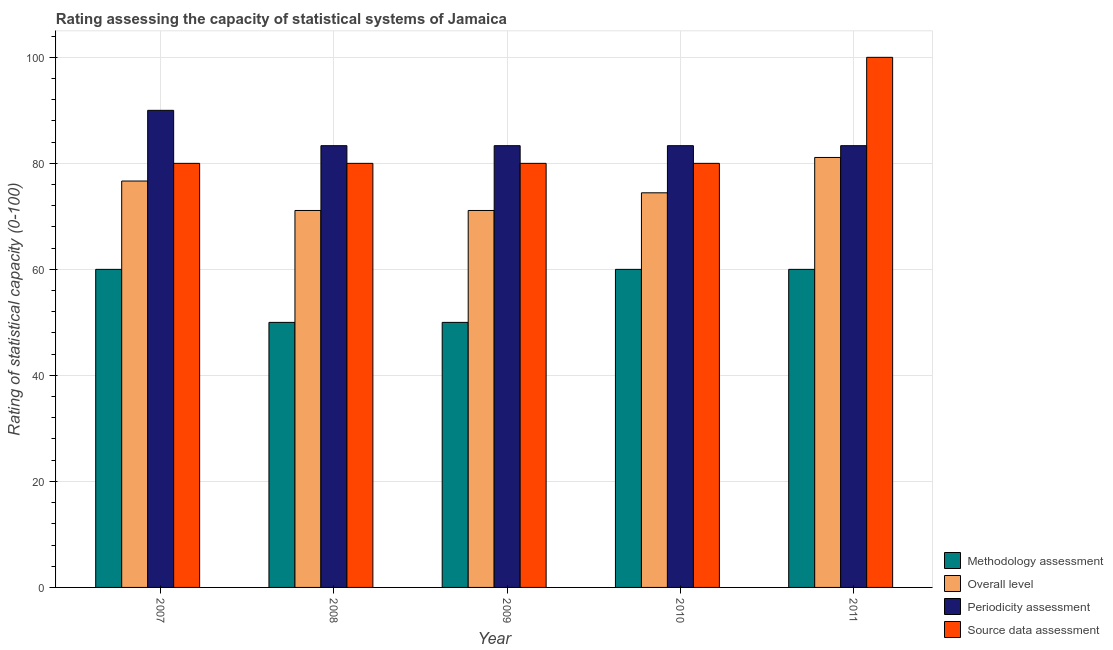How many different coloured bars are there?
Ensure brevity in your answer.  4. How many bars are there on the 3rd tick from the left?
Ensure brevity in your answer.  4. How many bars are there on the 5th tick from the right?
Your response must be concise. 4. What is the label of the 3rd group of bars from the left?
Your answer should be very brief. 2009. What is the source data assessment rating in 2008?
Provide a succinct answer. 80. Across all years, what is the maximum source data assessment rating?
Your answer should be very brief. 100. Across all years, what is the minimum methodology assessment rating?
Offer a terse response. 50. In which year was the methodology assessment rating maximum?
Ensure brevity in your answer.  2007. What is the total periodicity assessment rating in the graph?
Your answer should be very brief. 423.33. What is the difference between the periodicity assessment rating in 2009 and that in 2011?
Offer a terse response. 0. What is the average source data assessment rating per year?
Provide a short and direct response. 84. In the year 2008, what is the difference between the methodology assessment rating and periodicity assessment rating?
Your response must be concise. 0. What is the ratio of the overall level rating in 2008 to that in 2011?
Provide a short and direct response. 0.88. Is the overall level rating in 2010 less than that in 2011?
Provide a succinct answer. Yes. Is the difference between the methodology assessment rating in 2008 and 2011 greater than the difference between the source data assessment rating in 2008 and 2011?
Offer a terse response. No. What is the difference between the highest and the second highest overall level rating?
Provide a short and direct response. 4.44. What is the difference between the highest and the lowest source data assessment rating?
Your answer should be very brief. 20. Is the sum of the periodicity assessment rating in 2009 and 2010 greater than the maximum overall level rating across all years?
Give a very brief answer. Yes. Is it the case that in every year, the sum of the periodicity assessment rating and overall level rating is greater than the sum of source data assessment rating and methodology assessment rating?
Your answer should be very brief. Yes. What does the 1st bar from the left in 2009 represents?
Your response must be concise. Methodology assessment. What does the 1st bar from the right in 2008 represents?
Keep it short and to the point. Source data assessment. Is it the case that in every year, the sum of the methodology assessment rating and overall level rating is greater than the periodicity assessment rating?
Ensure brevity in your answer.  Yes. How many bars are there?
Ensure brevity in your answer.  20. Does the graph contain any zero values?
Offer a very short reply. No. How are the legend labels stacked?
Keep it short and to the point. Vertical. What is the title of the graph?
Offer a very short reply. Rating assessing the capacity of statistical systems of Jamaica. Does "Iceland" appear as one of the legend labels in the graph?
Offer a very short reply. No. What is the label or title of the Y-axis?
Offer a terse response. Rating of statistical capacity (0-100). What is the Rating of statistical capacity (0-100) in Methodology assessment in 2007?
Provide a succinct answer. 60. What is the Rating of statistical capacity (0-100) in Overall level in 2007?
Keep it short and to the point. 76.67. What is the Rating of statistical capacity (0-100) of Periodicity assessment in 2007?
Give a very brief answer. 90. What is the Rating of statistical capacity (0-100) of Source data assessment in 2007?
Provide a succinct answer. 80. What is the Rating of statistical capacity (0-100) in Methodology assessment in 2008?
Keep it short and to the point. 50. What is the Rating of statistical capacity (0-100) in Overall level in 2008?
Keep it short and to the point. 71.11. What is the Rating of statistical capacity (0-100) in Periodicity assessment in 2008?
Make the answer very short. 83.33. What is the Rating of statistical capacity (0-100) of Source data assessment in 2008?
Ensure brevity in your answer.  80. What is the Rating of statistical capacity (0-100) of Methodology assessment in 2009?
Provide a short and direct response. 50. What is the Rating of statistical capacity (0-100) of Overall level in 2009?
Your answer should be compact. 71.11. What is the Rating of statistical capacity (0-100) in Periodicity assessment in 2009?
Offer a terse response. 83.33. What is the Rating of statistical capacity (0-100) in Source data assessment in 2009?
Provide a short and direct response. 80. What is the Rating of statistical capacity (0-100) in Methodology assessment in 2010?
Provide a short and direct response. 60. What is the Rating of statistical capacity (0-100) of Overall level in 2010?
Ensure brevity in your answer.  74.44. What is the Rating of statistical capacity (0-100) in Periodicity assessment in 2010?
Your response must be concise. 83.33. What is the Rating of statistical capacity (0-100) of Overall level in 2011?
Give a very brief answer. 81.11. What is the Rating of statistical capacity (0-100) in Periodicity assessment in 2011?
Your response must be concise. 83.33. Across all years, what is the maximum Rating of statistical capacity (0-100) of Methodology assessment?
Ensure brevity in your answer.  60. Across all years, what is the maximum Rating of statistical capacity (0-100) in Overall level?
Your answer should be compact. 81.11. Across all years, what is the maximum Rating of statistical capacity (0-100) in Periodicity assessment?
Your answer should be very brief. 90. Across all years, what is the maximum Rating of statistical capacity (0-100) in Source data assessment?
Give a very brief answer. 100. Across all years, what is the minimum Rating of statistical capacity (0-100) of Overall level?
Provide a succinct answer. 71.11. Across all years, what is the minimum Rating of statistical capacity (0-100) of Periodicity assessment?
Keep it short and to the point. 83.33. What is the total Rating of statistical capacity (0-100) of Methodology assessment in the graph?
Your answer should be compact. 280. What is the total Rating of statistical capacity (0-100) in Overall level in the graph?
Offer a very short reply. 374.44. What is the total Rating of statistical capacity (0-100) of Periodicity assessment in the graph?
Keep it short and to the point. 423.33. What is the total Rating of statistical capacity (0-100) of Source data assessment in the graph?
Your response must be concise. 420. What is the difference between the Rating of statistical capacity (0-100) in Methodology assessment in 2007 and that in 2008?
Give a very brief answer. 10. What is the difference between the Rating of statistical capacity (0-100) of Overall level in 2007 and that in 2008?
Keep it short and to the point. 5.56. What is the difference between the Rating of statistical capacity (0-100) in Periodicity assessment in 2007 and that in 2008?
Provide a succinct answer. 6.67. What is the difference between the Rating of statistical capacity (0-100) of Methodology assessment in 2007 and that in 2009?
Provide a succinct answer. 10. What is the difference between the Rating of statistical capacity (0-100) in Overall level in 2007 and that in 2009?
Give a very brief answer. 5.56. What is the difference between the Rating of statistical capacity (0-100) of Periodicity assessment in 2007 and that in 2009?
Your response must be concise. 6.67. What is the difference between the Rating of statistical capacity (0-100) in Source data assessment in 2007 and that in 2009?
Ensure brevity in your answer.  0. What is the difference between the Rating of statistical capacity (0-100) in Overall level in 2007 and that in 2010?
Your answer should be compact. 2.22. What is the difference between the Rating of statistical capacity (0-100) in Source data assessment in 2007 and that in 2010?
Offer a terse response. 0. What is the difference between the Rating of statistical capacity (0-100) of Methodology assessment in 2007 and that in 2011?
Your response must be concise. 0. What is the difference between the Rating of statistical capacity (0-100) in Overall level in 2007 and that in 2011?
Provide a succinct answer. -4.44. What is the difference between the Rating of statistical capacity (0-100) in Source data assessment in 2007 and that in 2011?
Your answer should be compact. -20. What is the difference between the Rating of statistical capacity (0-100) of Periodicity assessment in 2008 and that in 2009?
Provide a succinct answer. 0. What is the difference between the Rating of statistical capacity (0-100) of Methodology assessment in 2008 and that in 2010?
Keep it short and to the point. -10. What is the difference between the Rating of statistical capacity (0-100) in Periodicity assessment in 2008 and that in 2010?
Provide a succinct answer. 0. What is the difference between the Rating of statistical capacity (0-100) in Periodicity assessment in 2008 and that in 2011?
Ensure brevity in your answer.  0. What is the difference between the Rating of statistical capacity (0-100) of Overall level in 2009 and that in 2010?
Your response must be concise. -3.33. What is the difference between the Rating of statistical capacity (0-100) of Periodicity assessment in 2009 and that in 2010?
Your answer should be compact. 0. What is the difference between the Rating of statistical capacity (0-100) of Periodicity assessment in 2009 and that in 2011?
Keep it short and to the point. 0. What is the difference between the Rating of statistical capacity (0-100) of Overall level in 2010 and that in 2011?
Make the answer very short. -6.67. What is the difference between the Rating of statistical capacity (0-100) in Periodicity assessment in 2010 and that in 2011?
Offer a very short reply. 0. What is the difference between the Rating of statistical capacity (0-100) of Source data assessment in 2010 and that in 2011?
Give a very brief answer. -20. What is the difference between the Rating of statistical capacity (0-100) in Methodology assessment in 2007 and the Rating of statistical capacity (0-100) in Overall level in 2008?
Your answer should be very brief. -11.11. What is the difference between the Rating of statistical capacity (0-100) in Methodology assessment in 2007 and the Rating of statistical capacity (0-100) in Periodicity assessment in 2008?
Offer a terse response. -23.33. What is the difference between the Rating of statistical capacity (0-100) in Overall level in 2007 and the Rating of statistical capacity (0-100) in Periodicity assessment in 2008?
Provide a succinct answer. -6.67. What is the difference between the Rating of statistical capacity (0-100) of Overall level in 2007 and the Rating of statistical capacity (0-100) of Source data assessment in 2008?
Offer a very short reply. -3.33. What is the difference between the Rating of statistical capacity (0-100) in Methodology assessment in 2007 and the Rating of statistical capacity (0-100) in Overall level in 2009?
Provide a short and direct response. -11.11. What is the difference between the Rating of statistical capacity (0-100) of Methodology assessment in 2007 and the Rating of statistical capacity (0-100) of Periodicity assessment in 2009?
Provide a short and direct response. -23.33. What is the difference between the Rating of statistical capacity (0-100) in Overall level in 2007 and the Rating of statistical capacity (0-100) in Periodicity assessment in 2009?
Keep it short and to the point. -6.67. What is the difference between the Rating of statistical capacity (0-100) of Periodicity assessment in 2007 and the Rating of statistical capacity (0-100) of Source data assessment in 2009?
Your answer should be very brief. 10. What is the difference between the Rating of statistical capacity (0-100) of Methodology assessment in 2007 and the Rating of statistical capacity (0-100) of Overall level in 2010?
Provide a short and direct response. -14.44. What is the difference between the Rating of statistical capacity (0-100) of Methodology assessment in 2007 and the Rating of statistical capacity (0-100) of Periodicity assessment in 2010?
Your response must be concise. -23.33. What is the difference between the Rating of statistical capacity (0-100) in Methodology assessment in 2007 and the Rating of statistical capacity (0-100) in Source data assessment in 2010?
Your response must be concise. -20. What is the difference between the Rating of statistical capacity (0-100) of Overall level in 2007 and the Rating of statistical capacity (0-100) of Periodicity assessment in 2010?
Your response must be concise. -6.67. What is the difference between the Rating of statistical capacity (0-100) of Overall level in 2007 and the Rating of statistical capacity (0-100) of Source data assessment in 2010?
Offer a terse response. -3.33. What is the difference between the Rating of statistical capacity (0-100) of Periodicity assessment in 2007 and the Rating of statistical capacity (0-100) of Source data assessment in 2010?
Provide a succinct answer. 10. What is the difference between the Rating of statistical capacity (0-100) of Methodology assessment in 2007 and the Rating of statistical capacity (0-100) of Overall level in 2011?
Provide a short and direct response. -21.11. What is the difference between the Rating of statistical capacity (0-100) of Methodology assessment in 2007 and the Rating of statistical capacity (0-100) of Periodicity assessment in 2011?
Make the answer very short. -23.33. What is the difference between the Rating of statistical capacity (0-100) of Overall level in 2007 and the Rating of statistical capacity (0-100) of Periodicity assessment in 2011?
Provide a succinct answer. -6.67. What is the difference between the Rating of statistical capacity (0-100) in Overall level in 2007 and the Rating of statistical capacity (0-100) in Source data assessment in 2011?
Offer a terse response. -23.33. What is the difference between the Rating of statistical capacity (0-100) of Periodicity assessment in 2007 and the Rating of statistical capacity (0-100) of Source data assessment in 2011?
Keep it short and to the point. -10. What is the difference between the Rating of statistical capacity (0-100) of Methodology assessment in 2008 and the Rating of statistical capacity (0-100) of Overall level in 2009?
Provide a succinct answer. -21.11. What is the difference between the Rating of statistical capacity (0-100) of Methodology assessment in 2008 and the Rating of statistical capacity (0-100) of Periodicity assessment in 2009?
Give a very brief answer. -33.33. What is the difference between the Rating of statistical capacity (0-100) in Methodology assessment in 2008 and the Rating of statistical capacity (0-100) in Source data assessment in 2009?
Your answer should be very brief. -30. What is the difference between the Rating of statistical capacity (0-100) of Overall level in 2008 and the Rating of statistical capacity (0-100) of Periodicity assessment in 2009?
Provide a succinct answer. -12.22. What is the difference between the Rating of statistical capacity (0-100) of Overall level in 2008 and the Rating of statistical capacity (0-100) of Source data assessment in 2009?
Your answer should be very brief. -8.89. What is the difference between the Rating of statistical capacity (0-100) of Methodology assessment in 2008 and the Rating of statistical capacity (0-100) of Overall level in 2010?
Give a very brief answer. -24.44. What is the difference between the Rating of statistical capacity (0-100) of Methodology assessment in 2008 and the Rating of statistical capacity (0-100) of Periodicity assessment in 2010?
Your response must be concise. -33.33. What is the difference between the Rating of statistical capacity (0-100) of Overall level in 2008 and the Rating of statistical capacity (0-100) of Periodicity assessment in 2010?
Provide a succinct answer. -12.22. What is the difference between the Rating of statistical capacity (0-100) in Overall level in 2008 and the Rating of statistical capacity (0-100) in Source data assessment in 2010?
Offer a terse response. -8.89. What is the difference between the Rating of statistical capacity (0-100) in Periodicity assessment in 2008 and the Rating of statistical capacity (0-100) in Source data assessment in 2010?
Provide a succinct answer. 3.33. What is the difference between the Rating of statistical capacity (0-100) of Methodology assessment in 2008 and the Rating of statistical capacity (0-100) of Overall level in 2011?
Offer a very short reply. -31.11. What is the difference between the Rating of statistical capacity (0-100) of Methodology assessment in 2008 and the Rating of statistical capacity (0-100) of Periodicity assessment in 2011?
Make the answer very short. -33.33. What is the difference between the Rating of statistical capacity (0-100) of Overall level in 2008 and the Rating of statistical capacity (0-100) of Periodicity assessment in 2011?
Provide a succinct answer. -12.22. What is the difference between the Rating of statistical capacity (0-100) of Overall level in 2008 and the Rating of statistical capacity (0-100) of Source data assessment in 2011?
Keep it short and to the point. -28.89. What is the difference between the Rating of statistical capacity (0-100) of Periodicity assessment in 2008 and the Rating of statistical capacity (0-100) of Source data assessment in 2011?
Make the answer very short. -16.67. What is the difference between the Rating of statistical capacity (0-100) of Methodology assessment in 2009 and the Rating of statistical capacity (0-100) of Overall level in 2010?
Offer a very short reply. -24.44. What is the difference between the Rating of statistical capacity (0-100) of Methodology assessment in 2009 and the Rating of statistical capacity (0-100) of Periodicity assessment in 2010?
Give a very brief answer. -33.33. What is the difference between the Rating of statistical capacity (0-100) in Overall level in 2009 and the Rating of statistical capacity (0-100) in Periodicity assessment in 2010?
Your response must be concise. -12.22. What is the difference between the Rating of statistical capacity (0-100) of Overall level in 2009 and the Rating of statistical capacity (0-100) of Source data assessment in 2010?
Your answer should be compact. -8.89. What is the difference between the Rating of statistical capacity (0-100) in Methodology assessment in 2009 and the Rating of statistical capacity (0-100) in Overall level in 2011?
Offer a very short reply. -31.11. What is the difference between the Rating of statistical capacity (0-100) in Methodology assessment in 2009 and the Rating of statistical capacity (0-100) in Periodicity assessment in 2011?
Your response must be concise. -33.33. What is the difference between the Rating of statistical capacity (0-100) of Overall level in 2009 and the Rating of statistical capacity (0-100) of Periodicity assessment in 2011?
Provide a short and direct response. -12.22. What is the difference between the Rating of statistical capacity (0-100) in Overall level in 2009 and the Rating of statistical capacity (0-100) in Source data assessment in 2011?
Offer a very short reply. -28.89. What is the difference between the Rating of statistical capacity (0-100) of Periodicity assessment in 2009 and the Rating of statistical capacity (0-100) of Source data assessment in 2011?
Offer a terse response. -16.67. What is the difference between the Rating of statistical capacity (0-100) of Methodology assessment in 2010 and the Rating of statistical capacity (0-100) of Overall level in 2011?
Offer a very short reply. -21.11. What is the difference between the Rating of statistical capacity (0-100) in Methodology assessment in 2010 and the Rating of statistical capacity (0-100) in Periodicity assessment in 2011?
Your answer should be very brief. -23.33. What is the difference between the Rating of statistical capacity (0-100) of Overall level in 2010 and the Rating of statistical capacity (0-100) of Periodicity assessment in 2011?
Give a very brief answer. -8.89. What is the difference between the Rating of statistical capacity (0-100) in Overall level in 2010 and the Rating of statistical capacity (0-100) in Source data assessment in 2011?
Provide a short and direct response. -25.56. What is the difference between the Rating of statistical capacity (0-100) of Periodicity assessment in 2010 and the Rating of statistical capacity (0-100) of Source data assessment in 2011?
Your answer should be compact. -16.67. What is the average Rating of statistical capacity (0-100) of Overall level per year?
Offer a very short reply. 74.89. What is the average Rating of statistical capacity (0-100) in Periodicity assessment per year?
Offer a terse response. 84.67. What is the average Rating of statistical capacity (0-100) of Source data assessment per year?
Your answer should be very brief. 84. In the year 2007, what is the difference between the Rating of statistical capacity (0-100) in Methodology assessment and Rating of statistical capacity (0-100) in Overall level?
Give a very brief answer. -16.67. In the year 2007, what is the difference between the Rating of statistical capacity (0-100) of Methodology assessment and Rating of statistical capacity (0-100) of Periodicity assessment?
Make the answer very short. -30. In the year 2007, what is the difference between the Rating of statistical capacity (0-100) of Methodology assessment and Rating of statistical capacity (0-100) of Source data assessment?
Ensure brevity in your answer.  -20. In the year 2007, what is the difference between the Rating of statistical capacity (0-100) of Overall level and Rating of statistical capacity (0-100) of Periodicity assessment?
Your response must be concise. -13.33. In the year 2008, what is the difference between the Rating of statistical capacity (0-100) of Methodology assessment and Rating of statistical capacity (0-100) of Overall level?
Provide a succinct answer. -21.11. In the year 2008, what is the difference between the Rating of statistical capacity (0-100) of Methodology assessment and Rating of statistical capacity (0-100) of Periodicity assessment?
Your answer should be very brief. -33.33. In the year 2008, what is the difference between the Rating of statistical capacity (0-100) of Methodology assessment and Rating of statistical capacity (0-100) of Source data assessment?
Ensure brevity in your answer.  -30. In the year 2008, what is the difference between the Rating of statistical capacity (0-100) in Overall level and Rating of statistical capacity (0-100) in Periodicity assessment?
Offer a terse response. -12.22. In the year 2008, what is the difference between the Rating of statistical capacity (0-100) in Overall level and Rating of statistical capacity (0-100) in Source data assessment?
Make the answer very short. -8.89. In the year 2009, what is the difference between the Rating of statistical capacity (0-100) of Methodology assessment and Rating of statistical capacity (0-100) of Overall level?
Provide a short and direct response. -21.11. In the year 2009, what is the difference between the Rating of statistical capacity (0-100) in Methodology assessment and Rating of statistical capacity (0-100) in Periodicity assessment?
Offer a terse response. -33.33. In the year 2009, what is the difference between the Rating of statistical capacity (0-100) of Overall level and Rating of statistical capacity (0-100) of Periodicity assessment?
Provide a short and direct response. -12.22. In the year 2009, what is the difference between the Rating of statistical capacity (0-100) of Overall level and Rating of statistical capacity (0-100) of Source data assessment?
Make the answer very short. -8.89. In the year 2010, what is the difference between the Rating of statistical capacity (0-100) in Methodology assessment and Rating of statistical capacity (0-100) in Overall level?
Provide a short and direct response. -14.44. In the year 2010, what is the difference between the Rating of statistical capacity (0-100) of Methodology assessment and Rating of statistical capacity (0-100) of Periodicity assessment?
Give a very brief answer. -23.33. In the year 2010, what is the difference between the Rating of statistical capacity (0-100) in Methodology assessment and Rating of statistical capacity (0-100) in Source data assessment?
Your response must be concise. -20. In the year 2010, what is the difference between the Rating of statistical capacity (0-100) of Overall level and Rating of statistical capacity (0-100) of Periodicity assessment?
Provide a succinct answer. -8.89. In the year 2010, what is the difference between the Rating of statistical capacity (0-100) in Overall level and Rating of statistical capacity (0-100) in Source data assessment?
Offer a very short reply. -5.56. In the year 2011, what is the difference between the Rating of statistical capacity (0-100) of Methodology assessment and Rating of statistical capacity (0-100) of Overall level?
Provide a short and direct response. -21.11. In the year 2011, what is the difference between the Rating of statistical capacity (0-100) in Methodology assessment and Rating of statistical capacity (0-100) in Periodicity assessment?
Your response must be concise. -23.33. In the year 2011, what is the difference between the Rating of statistical capacity (0-100) of Methodology assessment and Rating of statistical capacity (0-100) of Source data assessment?
Your response must be concise. -40. In the year 2011, what is the difference between the Rating of statistical capacity (0-100) in Overall level and Rating of statistical capacity (0-100) in Periodicity assessment?
Provide a succinct answer. -2.22. In the year 2011, what is the difference between the Rating of statistical capacity (0-100) in Overall level and Rating of statistical capacity (0-100) in Source data assessment?
Your answer should be very brief. -18.89. In the year 2011, what is the difference between the Rating of statistical capacity (0-100) in Periodicity assessment and Rating of statistical capacity (0-100) in Source data assessment?
Make the answer very short. -16.67. What is the ratio of the Rating of statistical capacity (0-100) in Overall level in 2007 to that in 2008?
Your answer should be very brief. 1.08. What is the ratio of the Rating of statistical capacity (0-100) of Periodicity assessment in 2007 to that in 2008?
Offer a terse response. 1.08. What is the ratio of the Rating of statistical capacity (0-100) of Overall level in 2007 to that in 2009?
Offer a terse response. 1.08. What is the ratio of the Rating of statistical capacity (0-100) of Source data assessment in 2007 to that in 2009?
Offer a terse response. 1. What is the ratio of the Rating of statistical capacity (0-100) in Overall level in 2007 to that in 2010?
Your answer should be very brief. 1.03. What is the ratio of the Rating of statistical capacity (0-100) of Periodicity assessment in 2007 to that in 2010?
Your answer should be compact. 1.08. What is the ratio of the Rating of statistical capacity (0-100) in Methodology assessment in 2007 to that in 2011?
Your response must be concise. 1. What is the ratio of the Rating of statistical capacity (0-100) in Overall level in 2007 to that in 2011?
Make the answer very short. 0.95. What is the ratio of the Rating of statistical capacity (0-100) in Source data assessment in 2007 to that in 2011?
Provide a short and direct response. 0.8. What is the ratio of the Rating of statistical capacity (0-100) of Methodology assessment in 2008 to that in 2010?
Provide a short and direct response. 0.83. What is the ratio of the Rating of statistical capacity (0-100) in Overall level in 2008 to that in 2010?
Provide a succinct answer. 0.96. What is the ratio of the Rating of statistical capacity (0-100) of Periodicity assessment in 2008 to that in 2010?
Offer a very short reply. 1. What is the ratio of the Rating of statistical capacity (0-100) of Source data assessment in 2008 to that in 2010?
Provide a short and direct response. 1. What is the ratio of the Rating of statistical capacity (0-100) of Overall level in 2008 to that in 2011?
Provide a succinct answer. 0.88. What is the ratio of the Rating of statistical capacity (0-100) in Source data assessment in 2008 to that in 2011?
Give a very brief answer. 0.8. What is the ratio of the Rating of statistical capacity (0-100) of Methodology assessment in 2009 to that in 2010?
Make the answer very short. 0.83. What is the ratio of the Rating of statistical capacity (0-100) in Overall level in 2009 to that in 2010?
Offer a terse response. 0.96. What is the ratio of the Rating of statistical capacity (0-100) in Periodicity assessment in 2009 to that in 2010?
Offer a very short reply. 1. What is the ratio of the Rating of statistical capacity (0-100) of Overall level in 2009 to that in 2011?
Offer a terse response. 0.88. What is the ratio of the Rating of statistical capacity (0-100) of Periodicity assessment in 2009 to that in 2011?
Offer a terse response. 1. What is the ratio of the Rating of statistical capacity (0-100) of Source data assessment in 2009 to that in 2011?
Provide a succinct answer. 0.8. What is the ratio of the Rating of statistical capacity (0-100) of Overall level in 2010 to that in 2011?
Offer a very short reply. 0.92. What is the ratio of the Rating of statistical capacity (0-100) of Periodicity assessment in 2010 to that in 2011?
Ensure brevity in your answer.  1. What is the ratio of the Rating of statistical capacity (0-100) of Source data assessment in 2010 to that in 2011?
Give a very brief answer. 0.8. What is the difference between the highest and the second highest Rating of statistical capacity (0-100) of Overall level?
Keep it short and to the point. 4.44. What is the difference between the highest and the second highest Rating of statistical capacity (0-100) of Periodicity assessment?
Ensure brevity in your answer.  6.67. What is the difference between the highest and the second highest Rating of statistical capacity (0-100) in Source data assessment?
Ensure brevity in your answer.  20. What is the difference between the highest and the lowest Rating of statistical capacity (0-100) of Methodology assessment?
Ensure brevity in your answer.  10. What is the difference between the highest and the lowest Rating of statistical capacity (0-100) of Overall level?
Your answer should be very brief. 10. What is the difference between the highest and the lowest Rating of statistical capacity (0-100) of Periodicity assessment?
Provide a succinct answer. 6.67. What is the difference between the highest and the lowest Rating of statistical capacity (0-100) of Source data assessment?
Offer a terse response. 20. 